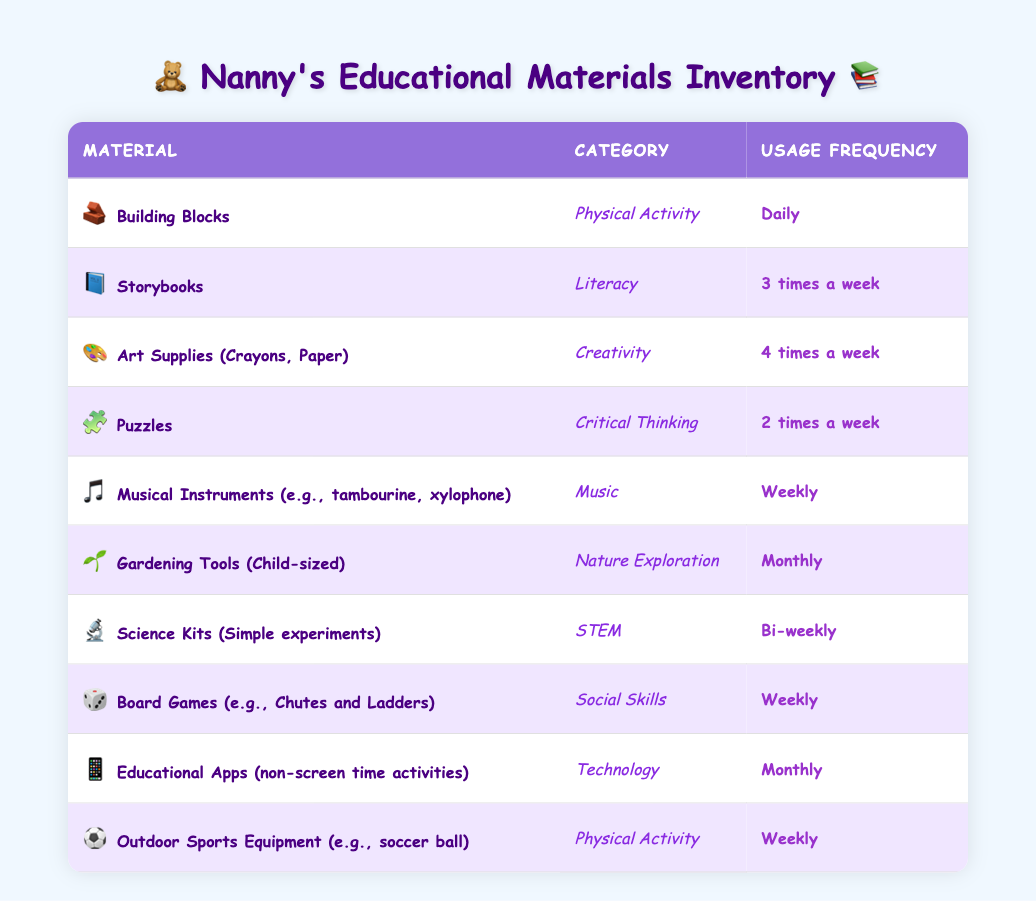What educational material is used daily? From the table, we can observe that "Building Blocks" is listed under the Usage Frequency column with "Daily" as its usage frequency.
Answer: Building Blocks How many materials are used weekly? By reviewing the Usage Frequency column, we see that there are four materials listed as used "Weekly": Musical Instruments, Board Games, Outdoor Sports Equipment.
Answer: 4 Which category does the material "Puzzles" belong to? In the table, the material "Puzzles" is found in the row that corresponds to the category, which is listed as "Critical Thinking."
Answer: Critical Thinking Is there any material categorized under "Nature Exploration"? In the table, "Gardening Tools (Child-sized)" is found in the category column marked as "Nature Exploration," confirming that such a material exists.
Answer: Yes What is the frequency of usage for "Science Kits"? The table clearly states that "Science Kits (Simple experiments)" are to be used "Bi-weekly," which is the frequency listed in the Usage Frequency column.
Answer: Bi-weekly How many times per week on average are creativity materials used? The only material in the Creativity category is "Art Supplies (Crayons, Paper)," used 4 times a week. Since there is only one material, the average is the same: 4.
Answer: 4 Which frequency is used more: "Weekly" or "Monthly"? Upon checking the table, "Weekly" is listed for four materials (Musical Instruments, Board Games, Outdoor Sports Equipment, and daily item Building Blocks), while "Monthly" has two materials (Gardening Tools and Educational Apps). Thus, "Weekly" is used more often.
Answer: Weekly What is the total number of materials used more than twice a week? The materials used more than twice a week are "Building Blocks" (Daily - 7 times), "Art Supplies (4 times a week)," "Storybooks" (3 times a week), and "Puzzles" (2 times). In total, there are four materials that fit this criterion.
Answer: 4 Which category has the least frequency of use listed in the table? By examining the materials, "Gardening Tools (Child-sized)" and "Educational Apps" are both in the "Monthly" frequency. Both reflect the least frequency of usage compared to the others.
Answer: Nature Exploration and Technology 